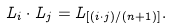Convert formula to latex. <formula><loc_0><loc_0><loc_500><loc_500>L _ { i } \cdot L _ { j } = L _ { [ ( i \cdot j ) / ( n + 1 ) ] } .</formula> 